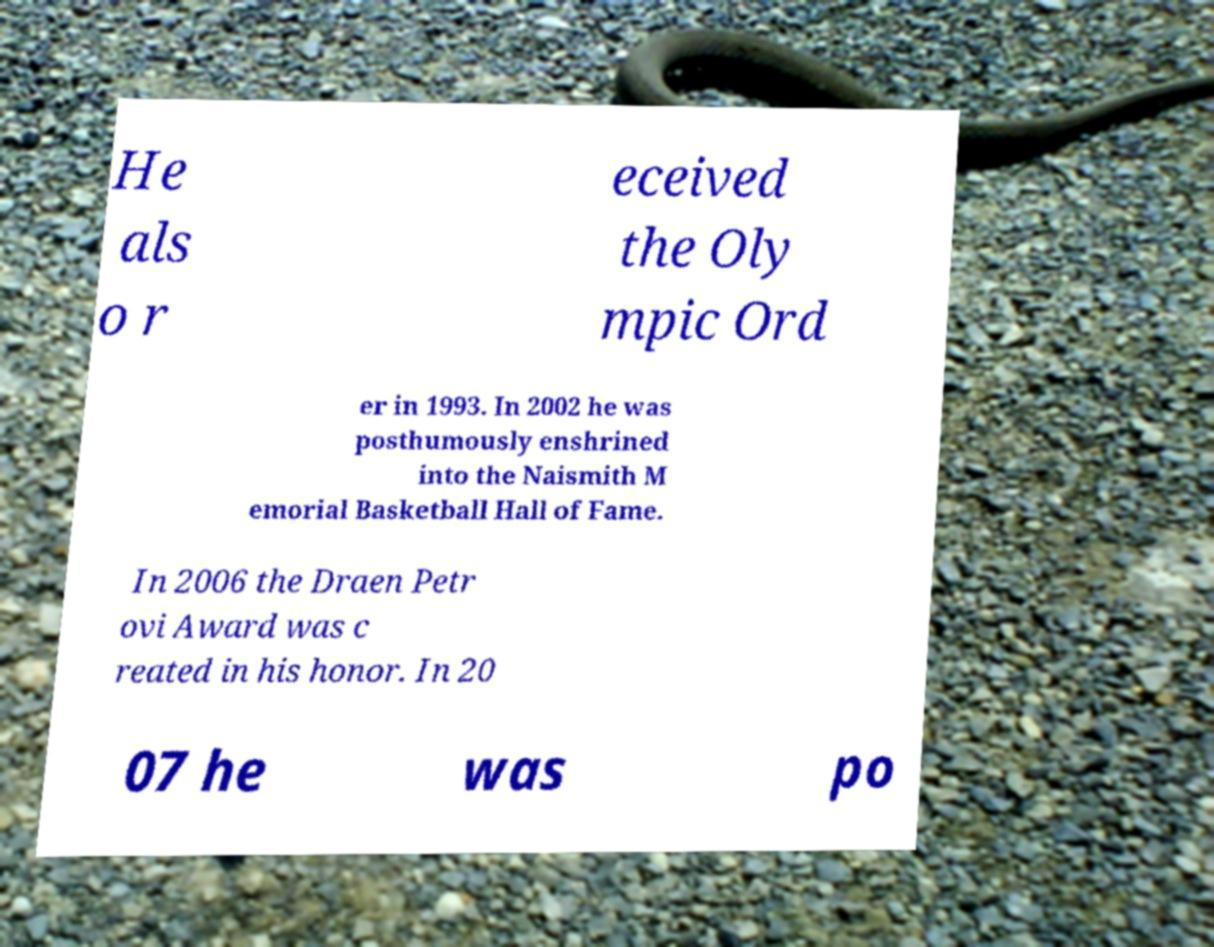Could you extract and type out the text from this image? He als o r eceived the Oly mpic Ord er in 1993. In 2002 he was posthumously enshrined into the Naismith M emorial Basketball Hall of Fame. In 2006 the Draen Petr ovi Award was c reated in his honor. In 20 07 he was po 